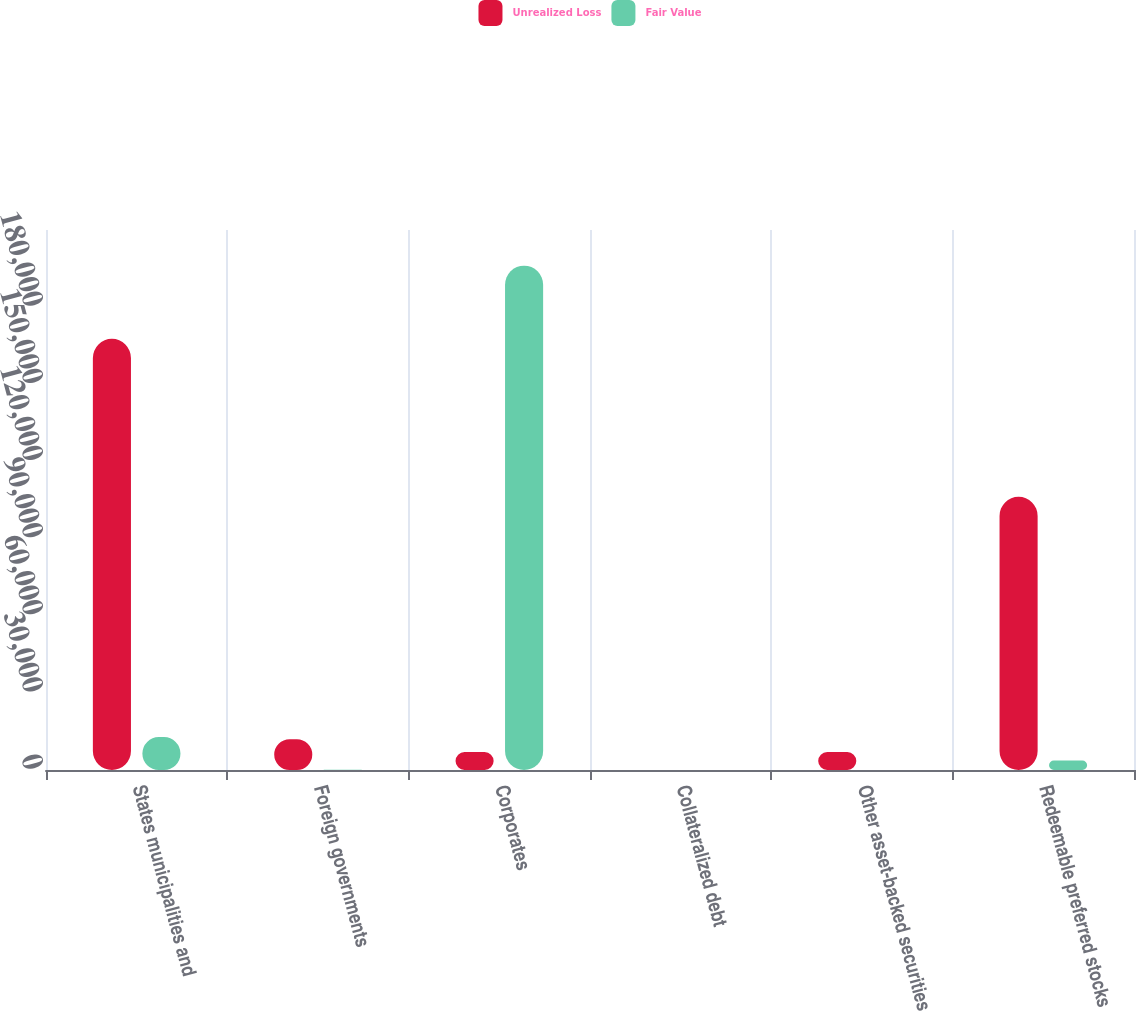Convert chart. <chart><loc_0><loc_0><loc_500><loc_500><stacked_bar_chart><ecel><fcel>States municipalities and<fcel>Foreign governments<fcel>Corporates<fcel>Collateralized debt<fcel>Other asset-backed securities<fcel>Redeemable preferred stocks<nl><fcel>Unrealized Loss<fcel>167660<fcel>11966<fcel>6974<fcel>0<fcel>6974<fcel>106229<nl><fcel>Fair Value<fcel>12807<fcel>67<fcel>196139<fcel>0<fcel>26<fcel>3694<nl></chart> 